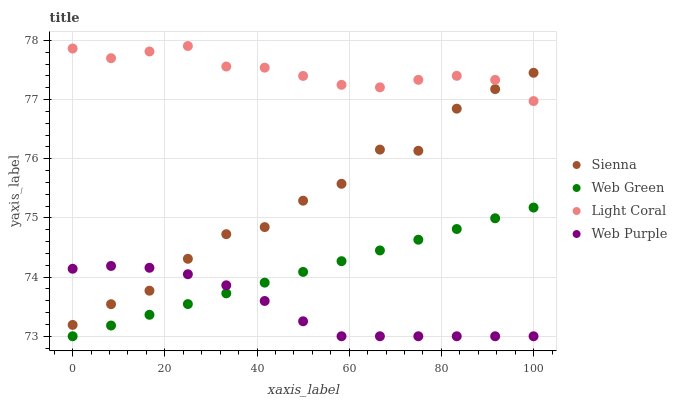Does Web Purple have the minimum area under the curve?
Answer yes or no. Yes. Does Light Coral have the maximum area under the curve?
Answer yes or no. Yes. Does Light Coral have the minimum area under the curve?
Answer yes or no. No. Does Web Purple have the maximum area under the curve?
Answer yes or no. No. Is Web Green the smoothest?
Answer yes or no. Yes. Is Sienna the roughest?
Answer yes or no. Yes. Is Light Coral the smoothest?
Answer yes or no. No. Is Light Coral the roughest?
Answer yes or no. No. Does Web Purple have the lowest value?
Answer yes or no. Yes. Does Light Coral have the lowest value?
Answer yes or no. No. Does Light Coral have the highest value?
Answer yes or no. Yes. Does Web Purple have the highest value?
Answer yes or no. No. Is Web Green less than Light Coral?
Answer yes or no. Yes. Is Sienna greater than Web Green?
Answer yes or no. Yes. Does Sienna intersect Web Purple?
Answer yes or no. Yes. Is Sienna less than Web Purple?
Answer yes or no. No. Is Sienna greater than Web Purple?
Answer yes or no. No. Does Web Green intersect Light Coral?
Answer yes or no. No. 